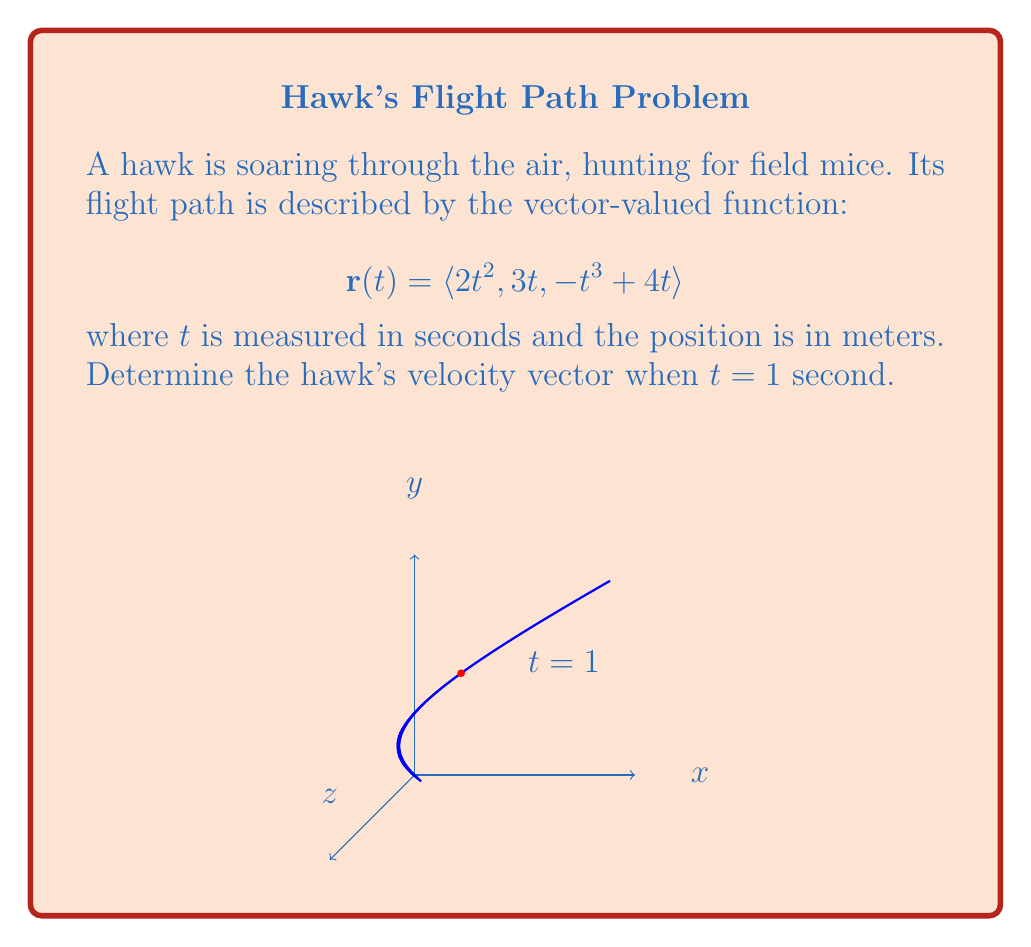Can you answer this question? To find the velocity vector, we need to differentiate the position vector $\mathbf{r}(t)$ with respect to time. The velocity vector is given by $\mathbf{v}(t) = \frac{d}{dt}\mathbf{r}(t)$.

Let's differentiate each component:

1) For the x-component: $\frac{d}{dt}(2t^2) = 4t$

2) For the y-component: $\frac{d}{dt}(3t) = 3$

3) For the z-component: $\frac{d}{dt}(-t^3 + 4t) = -3t^2 + 4$

Therefore, the velocity vector is:

$$\mathbf{v}(t) = \langle 4t, 3, -3t^2 + 4 \rangle$$

Now, we need to evaluate this at $t = 1$:

$$\mathbf{v}(1) = \langle 4(1), 3, -3(1)^2 + 4 \rangle = \langle 4, 3, 1 \rangle$$

This gives us the hawk's velocity vector one second into its flight.
Answer: $\langle 4, 3, 1 \rangle$ m/s 